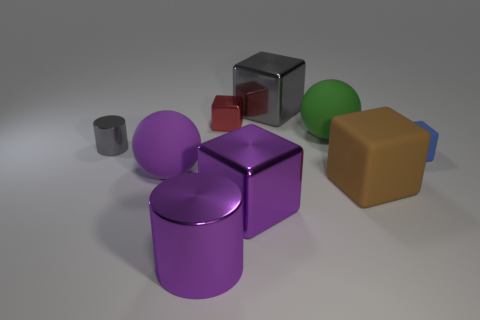Do the sphere that is on the left side of the gray shiny cube and the block to the right of the big brown rubber block have the same color?
Your answer should be very brief. No. There is a small metallic cylinder that is left of the brown rubber cube in front of the tiny blue rubber thing; how many tiny shiny objects are right of it?
Provide a succinct answer. 1. How many big things are in front of the blue matte block and behind the tiny cylinder?
Your answer should be very brief. 0. The thing that is the same color as the tiny cylinder is what size?
Your answer should be very brief. Large. Are there an equal number of tiny cylinders behind the gray cylinder and shiny blocks right of the brown matte object?
Offer a terse response. Yes. What is the color of the large ball that is right of the large gray cube?
Make the answer very short. Green. What is the material of the big purple object that is in front of the metal block in front of the tiny blue matte cube?
Offer a very short reply. Metal. Are there fewer big green objects that are in front of the big brown rubber thing than tiny blocks that are on the left side of the large green matte sphere?
Your response must be concise. Yes. What number of green objects are either large cylinders or tiny cylinders?
Give a very brief answer. 0. Are there an equal number of tiny blue objects left of the purple ball and small yellow balls?
Ensure brevity in your answer.  Yes. 